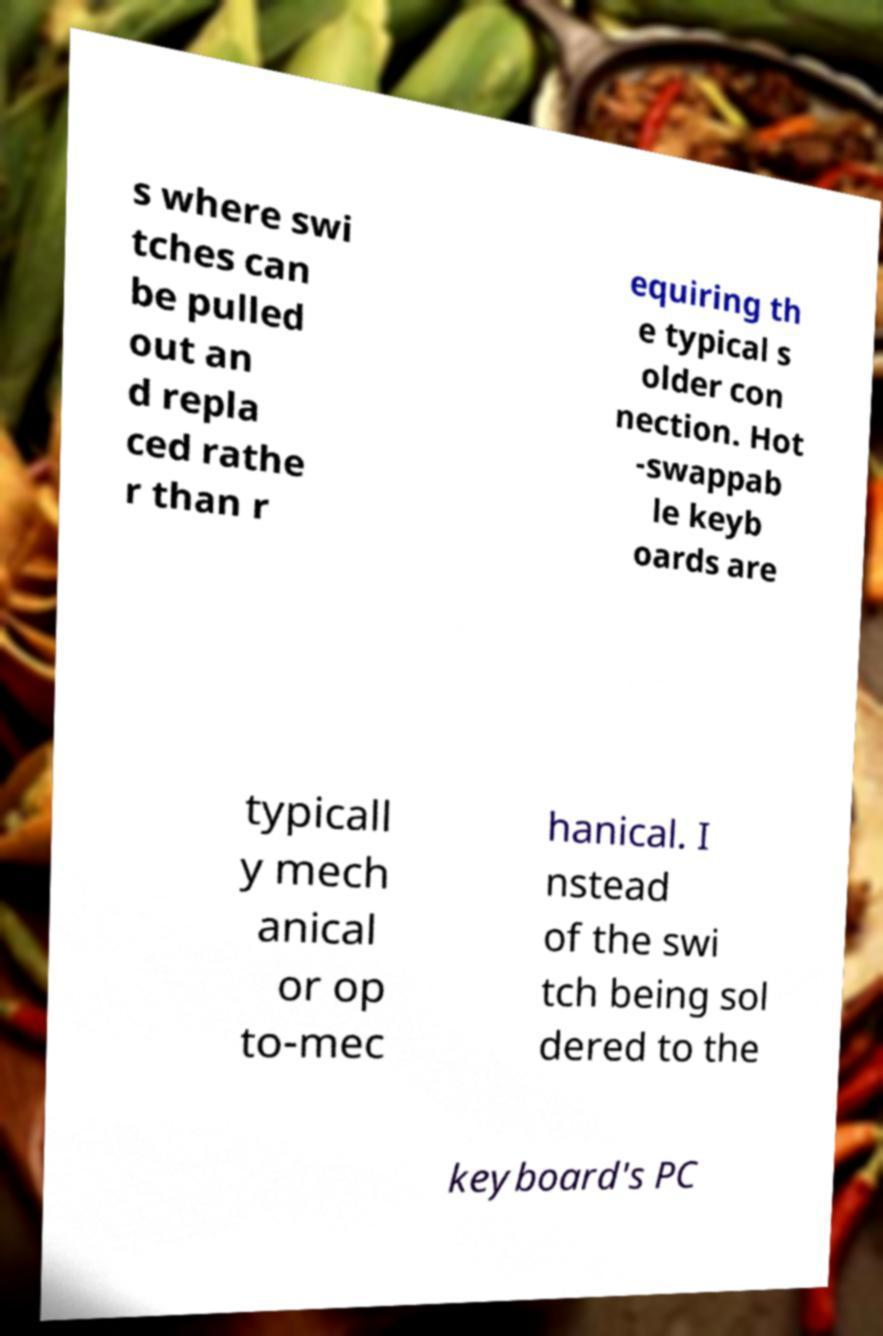Can you accurately transcribe the text from the provided image for me? s where swi tches can be pulled out an d repla ced rathe r than r equiring th e typical s older con nection. Hot -swappab le keyb oards are typicall y mech anical or op to-mec hanical. I nstead of the swi tch being sol dered to the keyboard's PC 